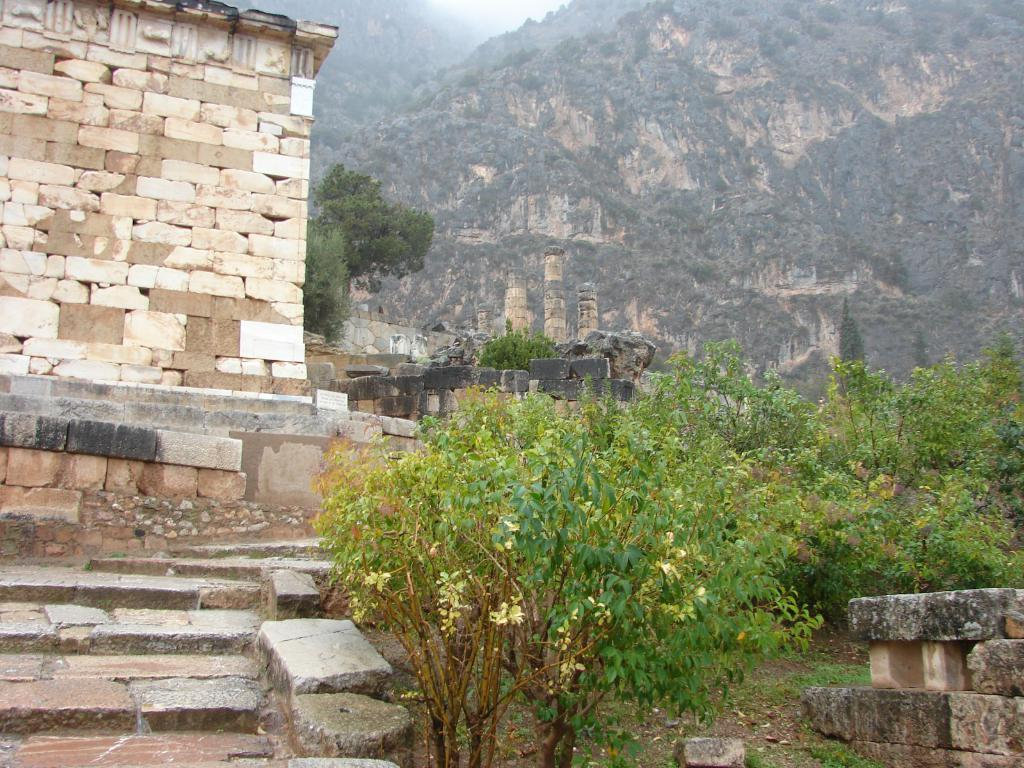What type of structure is on the left side of the image? There is a building with bricks on the left side of the image. What can be seen in front of the building? Trees and plants are visible in front of the building. What is visible in the background of the image? There are mountains in the background of the image. What type of noise can be heard coming from the head in the image? There is no head present in the image, so it is not possible to determine what, if any, noise might be heard. 